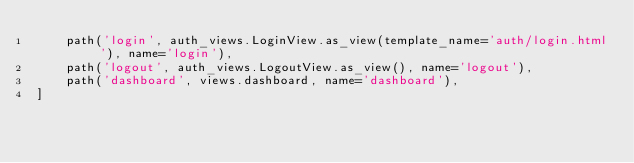<code> <loc_0><loc_0><loc_500><loc_500><_Python_>    path('login', auth_views.LoginView.as_view(template_name='auth/login.html'), name='login'),
    path('logout', auth_views.LogoutView.as_view(), name='logout'),
    path('dashboard', views.dashboard, name='dashboard'),
]
</code> 